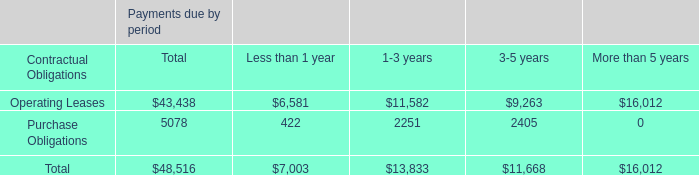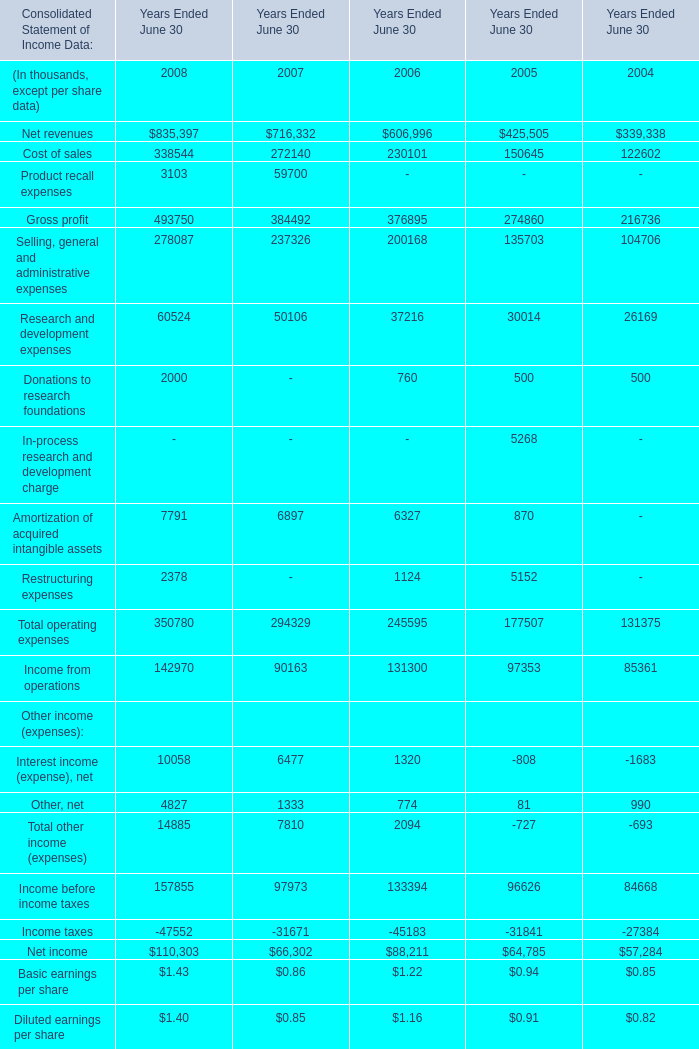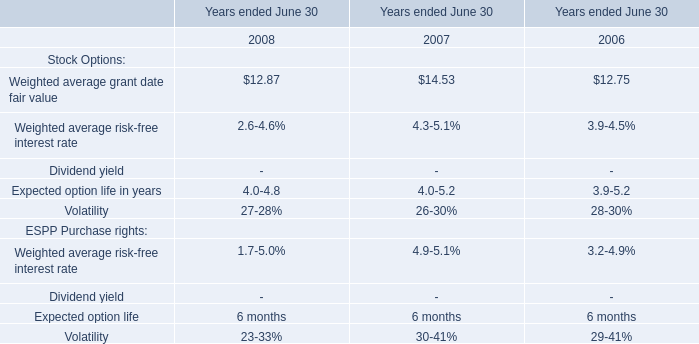What is the total amount of Research and development expenses of Years Ended June 30 2005, and Volatility of Years ended June 30 2008 ? 
Computations: (30014.0 + 2728.0)
Answer: 32742.0. 